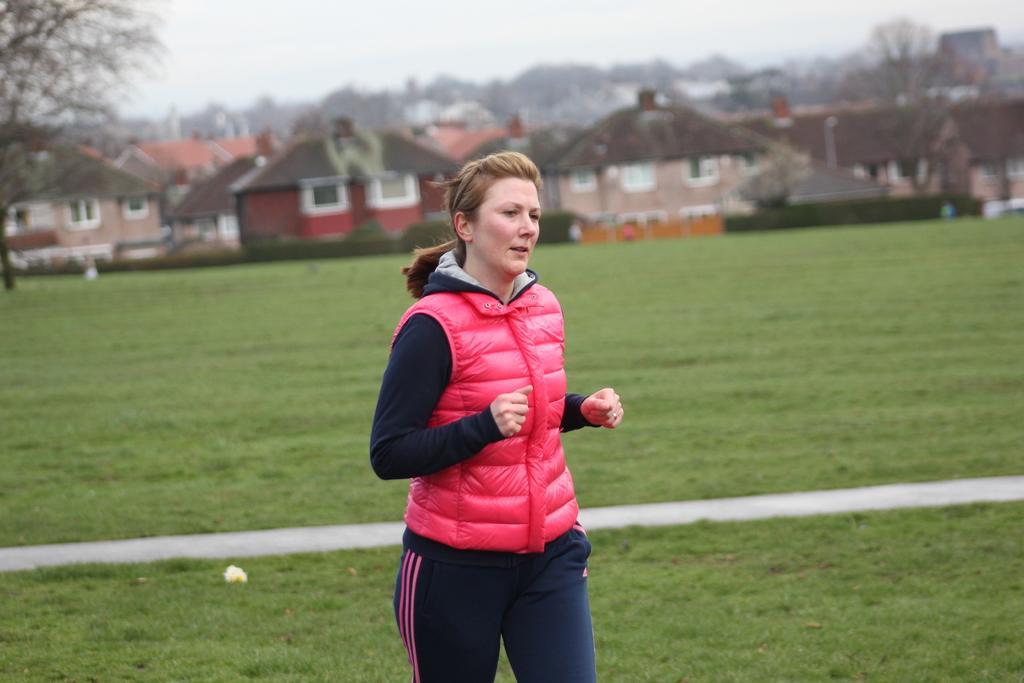How would you summarize this image in a sentence or two? In this image, I can see the woman standing. This is the grass. In the background, I can see the houses and the trees. I think this is the sky. 